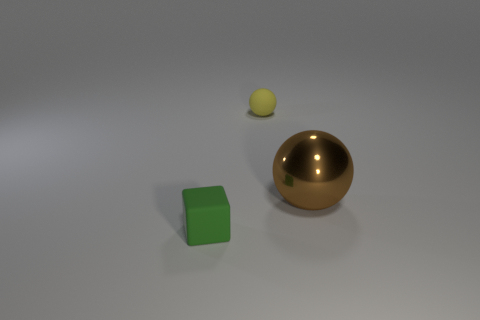Add 1 tiny yellow cylinders. How many objects exist? 4 Subtract all blocks. How many objects are left? 2 Subtract 0 cyan cylinders. How many objects are left? 3 Subtract all rubber balls. Subtract all big cyan matte cubes. How many objects are left? 2 Add 1 matte cubes. How many matte cubes are left? 2 Add 3 brown objects. How many brown objects exist? 4 